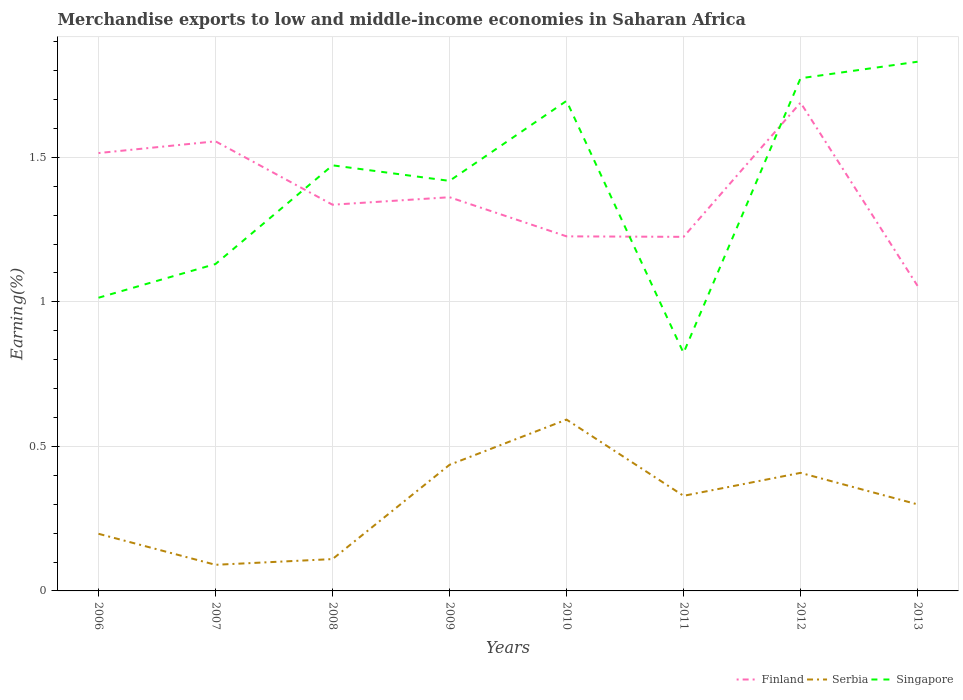Is the number of lines equal to the number of legend labels?
Make the answer very short. Yes. Across all years, what is the maximum percentage of amount earned from merchandise exports in Finland?
Make the answer very short. 1.06. In which year was the percentage of amount earned from merchandise exports in Serbia maximum?
Make the answer very short. 2007. What is the total percentage of amount earned from merchandise exports in Serbia in the graph?
Your answer should be compact. -0.1. What is the difference between the highest and the second highest percentage of amount earned from merchandise exports in Finland?
Make the answer very short. 0.63. What is the difference between the highest and the lowest percentage of amount earned from merchandise exports in Finland?
Offer a very short reply. 3. How many lines are there?
Your response must be concise. 3. What is the difference between two consecutive major ticks on the Y-axis?
Make the answer very short. 0.5. Are the values on the major ticks of Y-axis written in scientific E-notation?
Ensure brevity in your answer.  No. Does the graph contain any zero values?
Make the answer very short. No. How many legend labels are there?
Your answer should be very brief. 3. How are the legend labels stacked?
Offer a very short reply. Horizontal. What is the title of the graph?
Ensure brevity in your answer.  Merchandise exports to low and middle-income economies in Saharan Africa. Does "Samoa" appear as one of the legend labels in the graph?
Keep it short and to the point. No. What is the label or title of the Y-axis?
Your answer should be very brief. Earning(%). What is the Earning(%) in Finland in 2006?
Offer a very short reply. 1.51. What is the Earning(%) of Serbia in 2006?
Provide a short and direct response. 0.2. What is the Earning(%) of Singapore in 2006?
Provide a succinct answer. 1.01. What is the Earning(%) in Finland in 2007?
Your answer should be very brief. 1.56. What is the Earning(%) of Serbia in 2007?
Your answer should be compact. 0.09. What is the Earning(%) of Singapore in 2007?
Your response must be concise. 1.13. What is the Earning(%) of Finland in 2008?
Your answer should be very brief. 1.34. What is the Earning(%) in Serbia in 2008?
Ensure brevity in your answer.  0.11. What is the Earning(%) of Singapore in 2008?
Give a very brief answer. 1.47. What is the Earning(%) in Finland in 2009?
Provide a succinct answer. 1.36. What is the Earning(%) of Serbia in 2009?
Offer a very short reply. 0.44. What is the Earning(%) of Singapore in 2009?
Offer a very short reply. 1.42. What is the Earning(%) of Finland in 2010?
Offer a very short reply. 1.23. What is the Earning(%) in Serbia in 2010?
Provide a short and direct response. 0.59. What is the Earning(%) in Singapore in 2010?
Make the answer very short. 1.7. What is the Earning(%) of Finland in 2011?
Your answer should be compact. 1.22. What is the Earning(%) of Serbia in 2011?
Give a very brief answer. 0.33. What is the Earning(%) in Singapore in 2011?
Make the answer very short. 0.82. What is the Earning(%) in Finland in 2012?
Your response must be concise. 1.69. What is the Earning(%) of Serbia in 2012?
Provide a succinct answer. 0.41. What is the Earning(%) in Singapore in 2012?
Ensure brevity in your answer.  1.77. What is the Earning(%) of Finland in 2013?
Provide a short and direct response. 1.06. What is the Earning(%) in Serbia in 2013?
Offer a very short reply. 0.3. What is the Earning(%) in Singapore in 2013?
Your answer should be very brief. 1.83. Across all years, what is the maximum Earning(%) in Finland?
Provide a succinct answer. 1.69. Across all years, what is the maximum Earning(%) in Serbia?
Offer a terse response. 0.59. Across all years, what is the maximum Earning(%) in Singapore?
Ensure brevity in your answer.  1.83. Across all years, what is the minimum Earning(%) of Finland?
Offer a terse response. 1.06. Across all years, what is the minimum Earning(%) in Serbia?
Provide a short and direct response. 0.09. Across all years, what is the minimum Earning(%) of Singapore?
Make the answer very short. 0.82. What is the total Earning(%) of Finland in the graph?
Ensure brevity in your answer.  10.96. What is the total Earning(%) in Serbia in the graph?
Give a very brief answer. 2.46. What is the total Earning(%) in Singapore in the graph?
Give a very brief answer. 11.16. What is the difference between the Earning(%) in Finland in 2006 and that in 2007?
Your answer should be very brief. -0.04. What is the difference between the Earning(%) of Serbia in 2006 and that in 2007?
Your response must be concise. 0.11. What is the difference between the Earning(%) of Singapore in 2006 and that in 2007?
Your answer should be very brief. -0.12. What is the difference between the Earning(%) in Finland in 2006 and that in 2008?
Provide a short and direct response. 0.18. What is the difference between the Earning(%) of Serbia in 2006 and that in 2008?
Your response must be concise. 0.09. What is the difference between the Earning(%) of Singapore in 2006 and that in 2008?
Offer a very short reply. -0.46. What is the difference between the Earning(%) in Finland in 2006 and that in 2009?
Give a very brief answer. 0.15. What is the difference between the Earning(%) in Serbia in 2006 and that in 2009?
Offer a very short reply. -0.24. What is the difference between the Earning(%) in Singapore in 2006 and that in 2009?
Offer a very short reply. -0.4. What is the difference between the Earning(%) in Finland in 2006 and that in 2010?
Offer a very short reply. 0.29. What is the difference between the Earning(%) of Serbia in 2006 and that in 2010?
Give a very brief answer. -0.4. What is the difference between the Earning(%) in Singapore in 2006 and that in 2010?
Provide a short and direct response. -0.68. What is the difference between the Earning(%) of Finland in 2006 and that in 2011?
Keep it short and to the point. 0.29. What is the difference between the Earning(%) of Serbia in 2006 and that in 2011?
Offer a very short reply. -0.13. What is the difference between the Earning(%) of Singapore in 2006 and that in 2011?
Your response must be concise. 0.19. What is the difference between the Earning(%) in Finland in 2006 and that in 2012?
Provide a succinct answer. -0.17. What is the difference between the Earning(%) of Serbia in 2006 and that in 2012?
Offer a very short reply. -0.21. What is the difference between the Earning(%) of Singapore in 2006 and that in 2012?
Your answer should be compact. -0.76. What is the difference between the Earning(%) in Finland in 2006 and that in 2013?
Your response must be concise. 0.46. What is the difference between the Earning(%) of Serbia in 2006 and that in 2013?
Make the answer very short. -0.1. What is the difference between the Earning(%) in Singapore in 2006 and that in 2013?
Offer a very short reply. -0.82. What is the difference between the Earning(%) in Finland in 2007 and that in 2008?
Your answer should be very brief. 0.22. What is the difference between the Earning(%) in Serbia in 2007 and that in 2008?
Give a very brief answer. -0.02. What is the difference between the Earning(%) in Singapore in 2007 and that in 2008?
Provide a short and direct response. -0.34. What is the difference between the Earning(%) in Finland in 2007 and that in 2009?
Your answer should be very brief. 0.19. What is the difference between the Earning(%) in Serbia in 2007 and that in 2009?
Provide a short and direct response. -0.35. What is the difference between the Earning(%) of Singapore in 2007 and that in 2009?
Your response must be concise. -0.29. What is the difference between the Earning(%) of Finland in 2007 and that in 2010?
Give a very brief answer. 0.33. What is the difference between the Earning(%) in Serbia in 2007 and that in 2010?
Your answer should be compact. -0.5. What is the difference between the Earning(%) of Singapore in 2007 and that in 2010?
Provide a succinct answer. -0.56. What is the difference between the Earning(%) of Finland in 2007 and that in 2011?
Provide a short and direct response. 0.33. What is the difference between the Earning(%) of Serbia in 2007 and that in 2011?
Provide a short and direct response. -0.24. What is the difference between the Earning(%) in Singapore in 2007 and that in 2011?
Provide a short and direct response. 0.31. What is the difference between the Earning(%) of Finland in 2007 and that in 2012?
Provide a succinct answer. -0.13. What is the difference between the Earning(%) in Serbia in 2007 and that in 2012?
Offer a terse response. -0.32. What is the difference between the Earning(%) in Singapore in 2007 and that in 2012?
Offer a terse response. -0.64. What is the difference between the Earning(%) in Serbia in 2007 and that in 2013?
Give a very brief answer. -0.21. What is the difference between the Earning(%) of Singapore in 2007 and that in 2013?
Your answer should be compact. -0.7. What is the difference between the Earning(%) of Finland in 2008 and that in 2009?
Make the answer very short. -0.03. What is the difference between the Earning(%) in Serbia in 2008 and that in 2009?
Offer a terse response. -0.33. What is the difference between the Earning(%) of Singapore in 2008 and that in 2009?
Provide a succinct answer. 0.05. What is the difference between the Earning(%) of Finland in 2008 and that in 2010?
Your response must be concise. 0.11. What is the difference between the Earning(%) of Serbia in 2008 and that in 2010?
Your answer should be compact. -0.48. What is the difference between the Earning(%) of Singapore in 2008 and that in 2010?
Ensure brevity in your answer.  -0.22. What is the difference between the Earning(%) in Finland in 2008 and that in 2011?
Offer a terse response. 0.11. What is the difference between the Earning(%) in Serbia in 2008 and that in 2011?
Your answer should be very brief. -0.22. What is the difference between the Earning(%) of Singapore in 2008 and that in 2011?
Your answer should be compact. 0.65. What is the difference between the Earning(%) in Finland in 2008 and that in 2012?
Offer a very short reply. -0.35. What is the difference between the Earning(%) of Serbia in 2008 and that in 2012?
Your answer should be very brief. -0.3. What is the difference between the Earning(%) of Singapore in 2008 and that in 2012?
Provide a succinct answer. -0.3. What is the difference between the Earning(%) of Finland in 2008 and that in 2013?
Provide a short and direct response. 0.28. What is the difference between the Earning(%) in Serbia in 2008 and that in 2013?
Provide a short and direct response. -0.19. What is the difference between the Earning(%) of Singapore in 2008 and that in 2013?
Ensure brevity in your answer.  -0.36. What is the difference between the Earning(%) in Finland in 2009 and that in 2010?
Keep it short and to the point. 0.14. What is the difference between the Earning(%) of Serbia in 2009 and that in 2010?
Keep it short and to the point. -0.16. What is the difference between the Earning(%) in Singapore in 2009 and that in 2010?
Ensure brevity in your answer.  -0.28. What is the difference between the Earning(%) of Finland in 2009 and that in 2011?
Your response must be concise. 0.14. What is the difference between the Earning(%) in Serbia in 2009 and that in 2011?
Offer a very short reply. 0.11. What is the difference between the Earning(%) of Singapore in 2009 and that in 2011?
Provide a short and direct response. 0.59. What is the difference between the Earning(%) of Finland in 2009 and that in 2012?
Keep it short and to the point. -0.33. What is the difference between the Earning(%) in Serbia in 2009 and that in 2012?
Provide a short and direct response. 0.03. What is the difference between the Earning(%) of Singapore in 2009 and that in 2012?
Make the answer very short. -0.35. What is the difference between the Earning(%) of Finland in 2009 and that in 2013?
Ensure brevity in your answer.  0.31. What is the difference between the Earning(%) in Serbia in 2009 and that in 2013?
Provide a succinct answer. 0.14. What is the difference between the Earning(%) in Singapore in 2009 and that in 2013?
Your answer should be very brief. -0.41. What is the difference between the Earning(%) of Finland in 2010 and that in 2011?
Your answer should be compact. 0. What is the difference between the Earning(%) of Serbia in 2010 and that in 2011?
Give a very brief answer. 0.26. What is the difference between the Earning(%) of Singapore in 2010 and that in 2011?
Offer a very short reply. 0.87. What is the difference between the Earning(%) in Finland in 2010 and that in 2012?
Provide a short and direct response. -0.46. What is the difference between the Earning(%) in Serbia in 2010 and that in 2012?
Offer a terse response. 0.18. What is the difference between the Earning(%) in Singapore in 2010 and that in 2012?
Make the answer very short. -0.08. What is the difference between the Earning(%) of Finland in 2010 and that in 2013?
Your response must be concise. 0.17. What is the difference between the Earning(%) in Serbia in 2010 and that in 2013?
Keep it short and to the point. 0.29. What is the difference between the Earning(%) in Singapore in 2010 and that in 2013?
Offer a very short reply. -0.14. What is the difference between the Earning(%) of Finland in 2011 and that in 2012?
Give a very brief answer. -0.46. What is the difference between the Earning(%) of Serbia in 2011 and that in 2012?
Your answer should be compact. -0.08. What is the difference between the Earning(%) in Singapore in 2011 and that in 2012?
Give a very brief answer. -0.95. What is the difference between the Earning(%) in Finland in 2011 and that in 2013?
Provide a short and direct response. 0.17. What is the difference between the Earning(%) in Serbia in 2011 and that in 2013?
Ensure brevity in your answer.  0.03. What is the difference between the Earning(%) of Singapore in 2011 and that in 2013?
Provide a short and direct response. -1.01. What is the difference between the Earning(%) of Finland in 2012 and that in 2013?
Ensure brevity in your answer.  0.63. What is the difference between the Earning(%) of Serbia in 2012 and that in 2013?
Give a very brief answer. 0.11. What is the difference between the Earning(%) in Singapore in 2012 and that in 2013?
Provide a short and direct response. -0.06. What is the difference between the Earning(%) of Finland in 2006 and the Earning(%) of Serbia in 2007?
Your response must be concise. 1.42. What is the difference between the Earning(%) of Finland in 2006 and the Earning(%) of Singapore in 2007?
Provide a succinct answer. 0.38. What is the difference between the Earning(%) in Serbia in 2006 and the Earning(%) in Singapore in 2007?
Provide a succinct answer. -0.93. What is the difference between the Earning(%) of Finland in 2006 and the Earning(%) of Serbia in 2008?
Offer a terse response. 1.4. What is the difference between the Earning(%) in Finland in 2006 and the Earning(%) in Singapore in 2008?
Keep it short and to the point. 0.04. What is the difference between the Earning(%) of Serbia in 2006 and the Earning(%) of Singapore in 2008?
Ensure brevity in your answer.  -1.27. What is the difference between the Earning(%) of Finland in 2006 and the Earning(%) of Serbia in 2009?
Your answer should be very brief. 1.08. What is the difference between the Earning(%) in Finland in 2006 and the Earning(%) in Singapore in 2009?
Your answer should be very brief. 0.1. What is the difference between the Earning(%) in Serbia in 2006 and the Earning(%) in Singapore in 2009?
Give a very brief answer. -1.22. What is the difference between the Earning(%) of Finland in 2006 and the Earning(%) of Serbia in 2010?
Your answer should be very brief. 0.92. What is the difference between the Earning(%) of Finland in 2006 and the Earning(%) of Singapore in 2010?
Provide a succinct answer. -0.18. What is the difference between the Earning(%) in Serbia in 2006 and the Earning(%) in Singapore in 2010?
Give a very brief answer. -1.5. What is the difference between the Earning(%) in Finland in 2006 and the Earning(%) in Serbia in 2011?
Make the answer very short. 1.19. What is the difference between the Earning(%) in Finland in 2006 and the Earning(%) in Singapore in 2011?
Your answer should be very brief. 0.69. What is the difference between the Earning(%) in Serbia in 2006 and the Earning(%) in Singapore in 2011?
Ensure brevity in your answer.  -0.63. What is the difference between the Earning(%) of Finland in 2006 and the Earning(%) of Serbia in 2012?
Make the answer very short. 1.11. What is the difference between the Earning(%) in Finland in 2006 and the Earning(%) in Singapore in 2012?
Your answer should be very brief. -0.26. What is the difference between the Earning(%) of Serbia in 2006 and the Earning(%) of Singapore in 2012?
Give a very brief answer. -1.58. What is the difference between the Earning(%) of Finland in 2006 and the Earning(%) of Serbia in 2013?
Your response must be concise. 1.22. What is the difference between the Earning(%) of Finland in 2006 and the Earning(%) of Singapore in 2013?
Your answer should be compact. -0.32. What is the difference between the Earning(%) in Serbia in 2006 and the Earning(%) in Singapore in 2013?
Ensure brevity in your answer.  -1.63. What is the difference between the Earning(%) in Finland in 2007 and the Earning(%) in Serbia in 2008?
Make the answer very short. 1.45. What is the difference between the Earning(%) in Finland in 2007 and the Earning(%) in Singapore in 2008?
Your answer should be very brief. 0.08. What is the difference between the Earning(%) of Serbia in 2007 and the Earning(%) of Singapore in 2008?
Your response must be concise. -1.38. What is the difference between the Earning(%) of Finland in 2007 and the Earning(%) of Serbia in 2009?
Offer a very short reply. 1.12. What is the difference between the Earning(%) of Finland in 2007 and the Earning(%) of Singapore in 2009?
Ensure brevity in your answer.  0.14. What is the difference between the Earning(%) in Serbia in 2007 and the Earning(%) in Singapore in 2009?
Make the answer very short. -1.33. What is the difference between the Earning(%) of Finland in 2007 and the Earning(%) of Serbia in 2010?
Provide a short and direct response. 0.96. What is the difference between the Earning(%) of Finland in 2007 and the Earning(%) of Singapore in 2010?
Offer a terse response. -0.14. What is the difference between the Earning(%) in Serbia in 2007 and the Earning(%) in Singapore in 2010?
Keep it short and to the point. -1.6. What is the difference between the Earning(%) in Finland in 2007 and the Earning(%) in Serbia in 2011?
Provide a short and direct response. 1.23. What is the difference between the Earning(%) of Finland in 2007 and the Earning(%) of Singapore in 2011?
Offer a terse response. 0.73. What is the difference between the Earning(%) of Serbia in 2007 and the Earning(%) of Singapore in 2011?
Keep it short and to the point. -0.73. What is the difference between the Earning(%) of Finland in 2007 and the Earning(%) of Serbia in 2012?
Make the answer very short. 1.15. What is the difference between the Earning(%) of Finland in 2007 and the Earning(%) of Singapore in 2012?
Offer a terse response. -0.22. What is the difference between the Earning(%) of Serbia in 2007 and the Earning(%) of Singapore in 2012?
Your response must be concise. -1.68. What is the difference between the Earning(%) of Finland in 2007 and the Earning(%) of Serbia in 2013?
Offer a very short reply. 1.26. What is the difference between the Earning(%) of Finland in 2007 and the Earning(%) of Singapore in 2013?
Make the answer very short. -0.28. What is the difference between the Earning(%) of Serbia in 2007 and the Earning(%) of Singapore in 2013?
Offer a very short reply. -1.74. What is the difference between the Earning(%) of Finland in 2008 and the Earning(%) of Serbia in 2009?
Ensure brevity in your answer.  0.9. What is the difference between the Earning(%) of Finland in 2008 and the Earning(%) of Singapore in 2009?
Provide a short and direct response. -0.08. What is the difference between the Earning(%) of Serbia in 2008 and the Earning(%) of Singapore in 2009?
Provide a short and direct response. -1.31. What is the difference between the Earning(%) in Finland in 2008 and the Earning(%) in Serbia in 2010?
Give a very brief answer. 0.74. What is the difference between the Earning(%) of Finland in 2008 and the Earning(%) of Singapore in 2010?
Offer a terse response. -0.36. What is the difference between the Earning(%) of Serbia in 2008 and the Earning(%) of Singapore in 2010?
Your answer should be compact. -1.59. What is the difference between the Earning(%) of Finland in 2008 and the Earning(%) of Serbia in 2011?
Your answer should be very brief. 1.01. What is the difference between the Earning(%) in Finland in 2008 and the Earning(%) in Singapore in 2011?
Your response must be concise. 0.51. What is the difference between the Earning(%) in Serbia in 2008 and the Earning(%) in Singapore in 2011?
Offer a very short reply. -0.71. What is the difference between the Earning(%) in Finland in 2008 and the Earning(%) in Serbia in 2012?
Your answer should be very brief. 0.93. What is the difference between the Earning(%) of Finland in 2008 and the Earning(%) of Singapore in 2012?
Your response must be concise. -0.44. What is the difference between the Earning(%) in Serbia in 2008 and the Earning(%) in Singapore in 2012?
Ensure brevity in your answer.  -1.66. What is the difference between the Earning(%) of Finland in 2008 and the Earning(%) of Serbia in 2013?
Your answer should be very brief. 1.04. What is the difference between the Earning(%) of Finland in 2008 and the Earning(%) of Singapore in 2013?
Make the answer very short. -0.49. What is the difference between the Earning(%) in Serbia in 2008 and the Earning(%) in Singapore in 2013?
Keep it short and to the point. -1.72. What is the difference between the Earning(%) of Finland in 2009 and the Earning(%) of Serbia in 2010?
Keep it short and to the point. 0.77. What is the difference between the Earning(%) in Finland in 2009 and the Earning(%) in Singapore in 2010?
Give a very brief answer. -0.33. What is the difference between the Earning(%) in Serbia in 2009 and the Earning(%) in Singapore in 2010?
Provide a succinct answer. -1.26. What is the difference between the Earning(%) in Finland in 2009 and the Earning(%) in Serbia in 2011?
Offer a terse response. 1.03. What is the difference between the Earning(%) in Finland in 2009 and the Earning(%) in Singapore in 2011?
Your answer should be compact. 0.54. What is the difference between the Earning(%) in Serbia in 2009 and the Earning(%) in Singapore in 2011?
Make the answer very short. -0.39. What is the difference between the Earning(%) of Finland in 2009 and the Earning(%) of Serbia in 2012?
Provide a short and direct response. 0.95. What is the difference between the Earning(%) of Finland in 2009 and the Earning(%) of Singapore in 2012?
Provide a short and direct response. -0.41. What is the difference between the Earning(%) of Serbia in 2009 and the Earning(%) of Singapore in 2012?
Keep it short and to the point. -1.34. What is the difference between the Earning(%) in Finland in 2009 and the Earning(%) in Serbia in 2013?
Your answer should be very brief. 1.06. What is the difference between the Earning(%) of Finland in 2009 and the Earning(%) of Singapore in 2013?
Offer a very short reply. -0.47. What is the difference between the Earning(%) in Serbia in 2009 and the Earning(%) in Singapore in 2013?
Provide a succinct answer. -1.39. What is the difference between the Earning(%) in Finland in 2010 and the Earning(%) in Serbia in 2011?
Your answer should be compact. 0.9. What is the difference between the Earning(%) of Finland in 2010 and the Earning(%) of Singapore in 2011?
Your answer should be very brief. 0.4. What is the difference between the Earning(%) in Serbia in 2010 and the Earning(%) in Singapore in 2011?
Ensure brevity in your answer.  -0.23. What is the difference between the Earning(%) of Finland in 2010 and the Earning(%) of Serbia in 2012?
Your answer should be very brief. 0.82. What is the difference between the Earning(%) of Finland in 2010 and the Earning(%) of Singapore in 2012?
Make the answer very short. -0.55. What is the difference between the Earning(%) of Serbia in 2010 and the Earning(%) of Singapore in 2012?
Make the answer very short. -1.18. What is the difference between the Earning(%) of Finland in 2010 and the Earning(%) of Serbia in 2013?
Offer a terse response. 0.93. What is the difference between the Earning(%) of Finland in 2010 and the Earning(%) of Singapore in 2013?
Give a very brief answer. -0.6. What is the difference between the Earning(%) of Serbia in 2010 and the Earning(%) of Singapore in 2013?
Your answer should be compact. -1.24. What is the difference between the Earning(%) in Finland in 2011 and the Earning(%) in Serbia in 2012?
Ensure brevity in your answer.  0.82. What is the difference between the Earning(%) of Finland in 2011 and the Earning(%) of Singapore in 2012?
Offer a very short reply. -0.55. What is the difference between the Earning(%) in Serbia in 2011 and the Earning(%) in Singapore in 2012?
Make the answer very short. -1.44. What is the difference between the Earning(%) of Finland in 2011 and the Earning(%) of Serbia in 2013?
Your answer should be compact. 0.93. What is the difference between the Earning(%) of Finland in 2011 and the Earning(%) of Singapore in 2013?
Your answer should be very brief. -0.61. What is the difference between the Earning(%) in Serbia in 2011 and the Earning(%) in Singapore in 2013?
Provide a succinct answer. -1.5. What is the difference between the Earning(%) of Finland in 2012 and the Earning(%) of Serbia in 2013?
Keep it short and to the point. 1.39. What is the difference between the Earning(%) in Finland in 2012 and the Earning(%) in Singapore in 2013?
Your answer should be compact. -0.14. What is the difference between the Earning(%) in Serbia in 2012 and the Earning(%) in Singapore in 2013?
Give a very brief answer. -1.42. What is the average Earning(%) of Finland per year?
Keep it short and to the point. 1.37. What is the average Earning(%) in Serbia per year?
Provide a succinct answer. 0.31. What is the average Earning(%) of Singapore per year?
Offer a very short reply. 1.39. In the year 2006, what is the difference between the Earning(%) in Finland and Earning(%) in Serbia?
Make the answer very short. 1.32. In the year 2006, what is the difference between the Earning(%) of Finland and Earning(%) of Singapore?
Your answer should be compact. 0.5. In the year 2006, what is the difference between the Earning(%) of Serbia and Earning(%) of Singapore?
Keep it short and to the point. -0.82. In the year 2007, what is the difference between the Earning(%) of Finland and Earning(%) of Serbia?
Give a very brief answer. 1.47. In the year 2007, what is the difference between the Earning(%) in Finland and Earning(%) in Singapore?
Provide a succinct answer. 0.42. In the year 2007, what is the difference between the Earning(%) in Serbia and Earning(%) in Singapore?
Your response must be concise. -1.04. In the year 2008, what is the difference between the Earning(%) of Finland and Earning(%) of Serbia?
Your answer should be very brief. 1.23. In the year 2008, what is the difference between the Earning(%) in Finland and Earning(%) in Singapore?
Your response must be concise. -0.14. In the year 2008, what is the difference between the Earning(%) in Serbia and Earning(%) in Singapore?
Provide a short and direct response. -1.36. In the year 2009, what is the difference between the Earning(%) of Finland and Earning(%) of Serbia?
Make the answer very short. 0.93. In the year 2009, what is the difference between the Earning(%) in Finland and Earning(%) in Singapore?
Provide a short and direct response. -0.06. In the year 2009, what is the difference between the Earning(%) in Serbia and Earning(%) in Singapore?
Offer a very short reply. -0.98. In the year 2010, what is the difference between the Earning(%) in Finland and Earning(%) in Serbia?
Make the answer very short. 0.63. In the year 2010, what is the difference between the Earning(%) in Finland and Earning(%) in Singapore?
Your answer should be compact. -0.47. In the year 2010, what is the difference between the Earning(%) in Serbia and Earning(%) in Singapore?
Provide a short and direct response. -1.1. In the year 2011, what is the difference between the Earning(%) in Finland and Earning(%) in Serbia?
Offer a very short reply. 0.9. In the year 2011, what is the difference between the Earning(%) of Finland and Earning(%) of Singapore?
Give a very brief answer. 0.4. In the year 2011, what is the difference between the Earning(%) in Serbia and Earning(%) in Singapore?
Ensure brevity in your answer.  -0.49. In the year 2012, what is the difference between the Earning(%) of Finland and Earning(%) of Serbia?
Offer a terse response. 1.28. In the year 2012, what is the difference between the Earning(%) of Finland and Earning(%) of Singapore?
Keep it short and to the point. -0.08. In the year 2012, what is the difference between the Earning(%) in Serbia and Earning(%) in Singapore?
Provide a short and direct response. -1.37. In the year 2013, what is the difference between the Earning(%) in Finland and Earning(%) in Serbia?
Ensure brevity in your answer.  0.76. In the year 2013, what is the difference between the Earning(%) in Finland and Earning(%) in Singapore?
Provide a short and direct response. -0.78. In the year 2013, what is the difference between the Earning(%) of Serbia and Earning(%) of Singapore?
Make the answer very short. -1.53. What is the ratio of the Earning(%) of Finland in 2006 to that in 2007?
Provide a succinct answer. 0.97. What is the ratio of the Earning(%) in Serbia in 2006 to that in 2007?
Provide a short and direct response. 2.19. What is the ratio of the Earning(%) of Singapore in 2006 to that in 2007?
Give a very brief answer. 0.9. What is the ratio of the Earning(%) in Finland in 2006 to that in 2008?
Keep it short and to the point. 1.13. What is the ratio of the Earning(%) in Serbia in 2006 to that in 2008?
Your answer should be very brief. 1.79. What is the ratio of the Earning(%) in Singapore in 2006 to that in 2008?
Your response must be concise. 0.69. What is the ratio of the Earning(%) in Finland in 2006 to that in 2009?
Your response must be concise. 1.11. What is the ratio of the Earning(%) of Serbia in 2006 to that in 2009?
Ensure brevity in your answer.  0.45. What is the ratio of the Earning(%) of Singapore in 2006 to that in 2009?
Ensure brevity in your answer.  0.71. What is the ratio of the Earning(%) of Finland in 2006 to that in 2010?
Provide a succinct answer. 1.23. What is the ratio of the Earning(%) in Serbia in 2006 to that in 2010?
Offer a terse response. 0.33. What is the ratio of the Earning(%) in Singapore in 2006 to that in 2010?
Offer a very short reply. 0.6. What is the ratio of the Earning(%) in Finland in 2006 to that in 2011?
Offer a very short reply. 1.24. What is the ratio of the Earning(%) in Serbia in 2006 to that in 2011?
Give a very brief answer. 0.6. What is the ratio of the Earning(%) in Singapore in 2006 to that in 2011?
Offer a terse response. 1.23. What is the ratio of the Earning(%) in Finland in 2006 to that in 2012?
Keep it short and to the point. 0.9. What is the ratio of the Earning(%) of Serbia in 2006 to that in 2012?
Provide a succinct answer. 0.48. What is the ratio of the Earning(%) in Singapore in 2006 to that in 2012?
Offer a terse response. 0.57. What is the ratio of the Earning(%) of Finland in 2006 to that in 2013?
Your answer should be compact. 1.44. What is the ratio of the Earning(%) in Serbia in 2006 to that in 2013?
Offer a very short reply. 0.66. What is the ratio of the Earning(%) in Singapore in 2006 to that in 2013?
Offer a terse response. 0.55. What is the ratio of the Earning(%) in Finland in 2007 to that in 2008?
Your response must be concise. 1.16. What is the ratio of the Earning(%) in Serbia in 2007 to that in 2008?
Your answer should be compact. 0.82. What is the ratio of the Earning(%) of Singapore in 2007 to that in 2008?
Give a very brief answer. 0.77. What is the ratio of the Earning(%) of Finland in 2007 to that in 2009?
Ensure brevity in your answer.  1.14. What is the ratio of the Earning(%) in Serbia in 2007 to that in 2009?
Your answer should be compact. 0.21. What is the ratio of the Earning(%) in Singapore in 2007 to that in 2009?
Ensure brevity in your answer.  0.8. What is the ratio of the Earning(%) in Finland in 2007 to that in 2010?
Give a very brief answer. 1.27. What is the ratio of the Earning(%) in Serbia in 2007 to that in 2010?
Offer a terse response. 0.15. What is the ratio of the Earning(%) in Singapore in 2007 to that in 2010?
Make the answer very short. 0.67. What is the ratio of the Earning(%) in Finland in 2007 to that in 2011?
Provide a succinct answer. 1.27. What is the ratio of the Earning(%) in Serbia in 2007 to that in 2011?
Your answer should be compact. 0.27. What is the ratio of the Earning(%) in Singapore in 2007 to that in 2011?
Offer a very short reply. 1.37. What is the ratio of the Earning(%) in Finland in 2007 to that in 2012?
Your answer should be compact. 0.92. What is the ratio of the Earning(%) in Serbia in 2007 to that in 2012?
Keep it short and to the point. 0.22. What is the ratio of the Earning(%) of Singapore in 2007 to that in 2012?
Your answer should be very brief. 0.64. What is the ratio of the Earning(%) in Finland in 2007 to that in 2013?
Your answer should be compact. 1.47. What is the ratio of the Earning(%) of Serbia in 2007 to that in 2013?
Keep it short and to the point. 0.3. What is the ratio of the Earning(%) in Singapore in 2007 to that in 2013?
Your answer should be compact. 0.62. What is the ratio of the Earning(%) in Finland in 2008 to that in 2009?
Give a very brief answer. 0.98. What is the ratio of the Earning(%) in Serbia in 2008 to that in 2009?
Keep it short and to the point. 0.25. What is the ratio of the Earning(%) of Singapore in 2008 to that in 2009?
Your answer should be very brief. 1.04. What is the ratio of the Earning(%) in Finland in 2008 to that in 2010?
Your answer should be very brief. 1.09. What is the ratio of the Earning(%) of Serbia in 2008 to that in 2010?
Offer a terse response. 0.19. What is the ratio of the Earning(%) in Singapore in 2008 to that in 2010?
Your answer should be compact. 0.87. What is the ratio of the Earning(%) in Finland in 2008 to that in 2011?
Your response must be concise. 1.09. What is the ratio of the Earning(%) in Serbia in 2008 to that in 2011?
Provide a short and direct response. 0.33. What is the ratio of the Earning(%) of Singapore in 2008 to that in 2011?
Your response must be concise. 1.79. What is the ratio of the Earning(%) of Finland in 2008 to that in 2012?
Provide a succinct answer. 0.79. What is the ratio of the Earning(%) in Serbia in 2008 to that in 2012?
Make the answer very short. 0.27. What is the ratio of the Earning(%) of Singapore in 2008 to that in 2012?
Keep it short and to the point. 0.83. What is the ratio of the Earning(%) of Finland in 2008 to that in 2013?
Offer a terse response. 1.27. What is the ratio of the Earning(%) of Serbia in 2008 to that in 2013?
Provide a short and direct response. 0.37. What is the ratio of the Earning(%) of Singapore in 2008 to that in 2013?
Your response must be concise. 0.8. What is the ratio of the Earning(%) in Finland in 2009 to that in 2010?
Give a very brief answer. 1.11. What is the ratio of the Earning(%) of Serbia in 2009 to that in 2010?
Offer a terse response. 0.74. What is the ratio of the Earning(%) in Singapore in 2009 to that in 2010?
Keep it short and to the point. 0.84. What is the ratio of the Earning(%) in Finland in 2009 to that in 2011?
Your response must be concise. 1.11. What is the ratio of the Earning(%) in Serbia in 2009 to that in 2011?
Ensure brevity in your answer.  1.33. What is the ratio of the Earning(%) in Singapore in 2009 to that in 2011?
Keep it short and to the point. 1.72. What is the ratio of the Earning(%) of Finland in 2009 to that in 2012?
Your answer should be compact. 0.81. What is the ratio of the Earning(%) of Serbia in 2009 to that in 2012?
Your answer should be compact. 1.07. What is the ratio of the Earning(%) in Singapore in 2009 to that in 2012?
Keep it short and to the point. 0.8. What is the ratio of the Earning(%) of Finland in 2009 to that in 2013?
Ensure brevity in your answer.  1.29. What is the ratio of the Earning(%) in Serbia in 2009 to that in 2013?
Your answer should be compact. 1.46. What is the ratio of the Earning(%) of Singapore in 2009 to that in 2013?
Ensure brevity in your answer.  0.77. What is the ratio of the Earning(%) in Serbia in 2010 to that in 2011?
Make the answer very short. 1.8. What is the ratio of the Earning(%) of Singapore in 2010 to that in 2011?
Your answer should be very brief. 2.06. What is the ratio of the Earning(%) of Finland in 2010 to that in 2012?
Keep it short and to the point. 0.73. What is the ratio of the Earning(%) of Serbia in 2010 to that in 2012?
Provide a succinct answer. 1.45. What is the ratio of the Earning(%) of Singapore in 2010 to that in 2012?
Give a very brief answer. 0.96. What is the ratio of the Earning(%) in Finland in 2010 to that in 2013?
Your response must be concise. 1.16. What is the ratio of the Earning(%) in Serbia in 2010 to that in 2013?
Your answer should be compact. 1.98. What is the ratio of the Earning(%) of Singapore in 2010 to that in 2013?
Your answer should be compact. 0.93. What is the ratio of the Earning(%) in Finland in 2011 to that in 2012?
Provide a succinct answer. 0.73. What is the ratio of the Earning(%) of Serbia in 2011 to that in 2012?
Offer a very short reply. 0.81. What is the ratio of the Earning(%) in Singapore in 2011 to that in 2012?
Offer a terse response. 0.46. What is the ratio of the Earning(%) in Finland in 2011 to that in 2013?
Your answer should be compact. 1.16. What is the ratio of the Earning(%) in Serbia in 2011 to that in 2013?
Your answer should be very brief. 1.1. What is the ratio of the Earning(%) of Singapore in 2011 to that in 2013?
Your answer should be compact. 0.45. What is the ratio of the Earning(%) of Finland in 2012 to that in 2013?
Make the answer very short. 1.6. What is the ratio of the Earning(%) of Serbia in 2012 to that in 2013?
Your answer should be compact. 1.36. What is the ratio of the Earning(%) of Singapore in 2012 to that in 2013?
Offer a terse response. 0.97. What is the difference between the highest and the second highest Earning(%) in Finland?
Provide a short and direct response. 0.13. What is the difference between the highest and the second highest Earning(%) in Serbia?
Your answer should be very brief. 0.16. What is the difference between the highest and the second highest Earning(%) in Singapore?
Provide a succinct answer. 0.06. What is the difference between the highest and the lowest Earning(%) in Finland?
Make the answer very short. 0.63. What is the difference between the highest and the lowest Earning(%) of Serbia?
Your response must be concise. 0.5. 